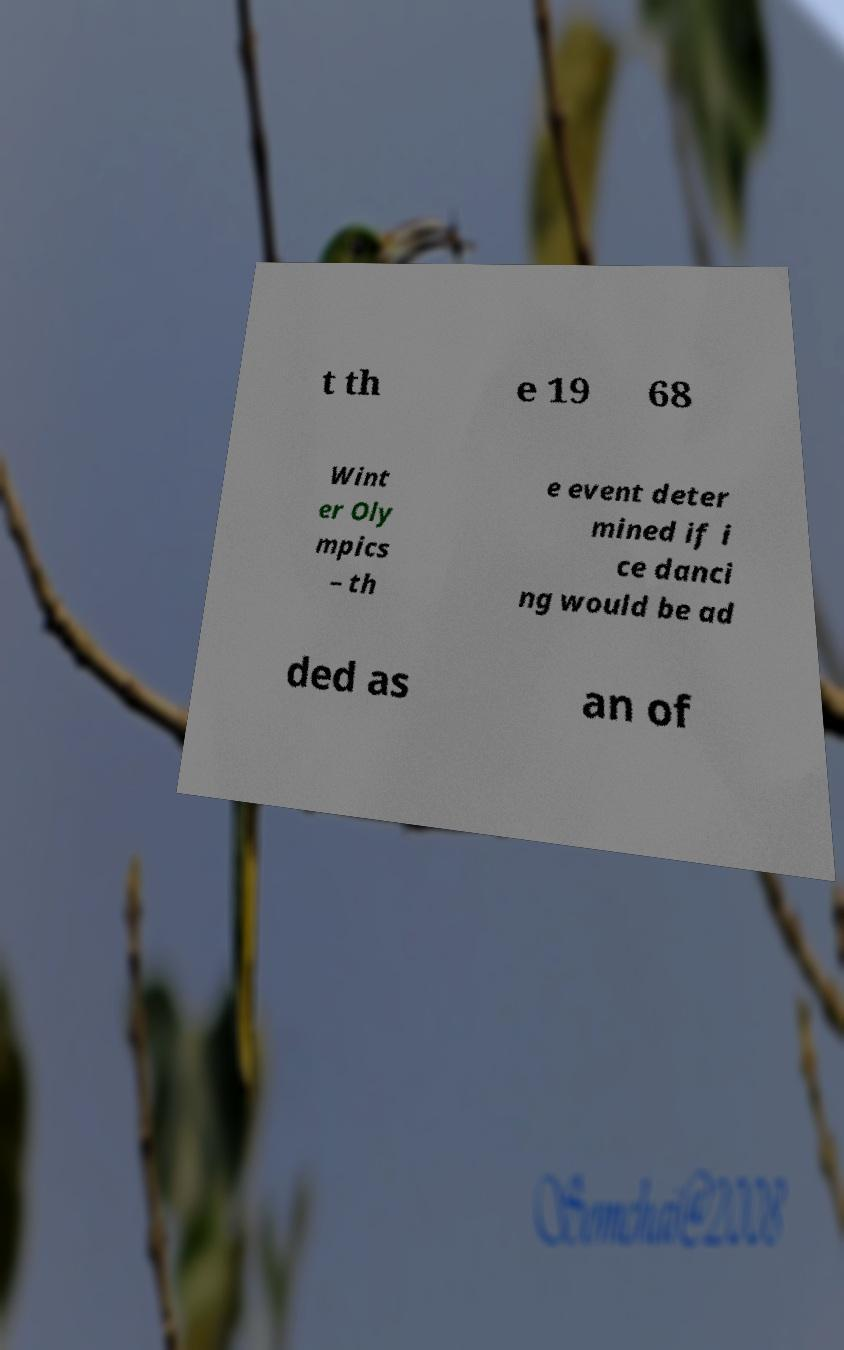Please identify and transcribe the text found in this image. t th e 19 68 Wint er Oly mpics – th e event deter mined if i ce danci ng would be ad ded as an of 